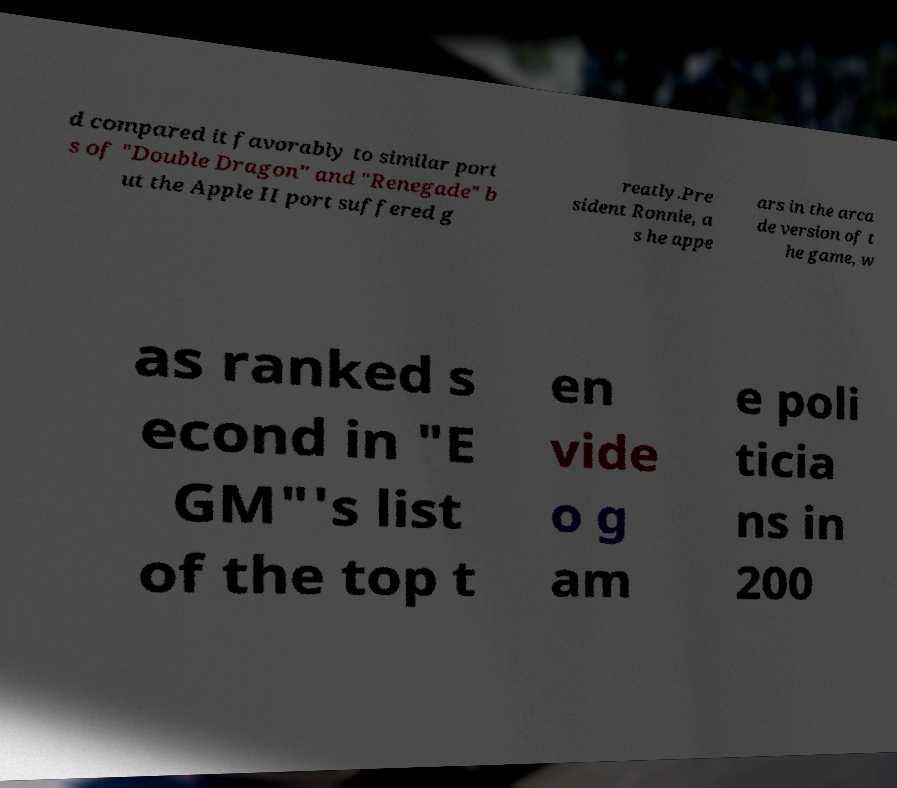Could you extract and type out the text from this image? d compared it favorably to similar port s of "Double Dragon" and "Renegade" b ut the Apple II port suffered g reatly.Pre sident Ronnie, a s he appe ars in the arca de version of t he game, w as ranked s econd in "E GM"'s list of the top t en vide o g am e poli ticia ns in 200 